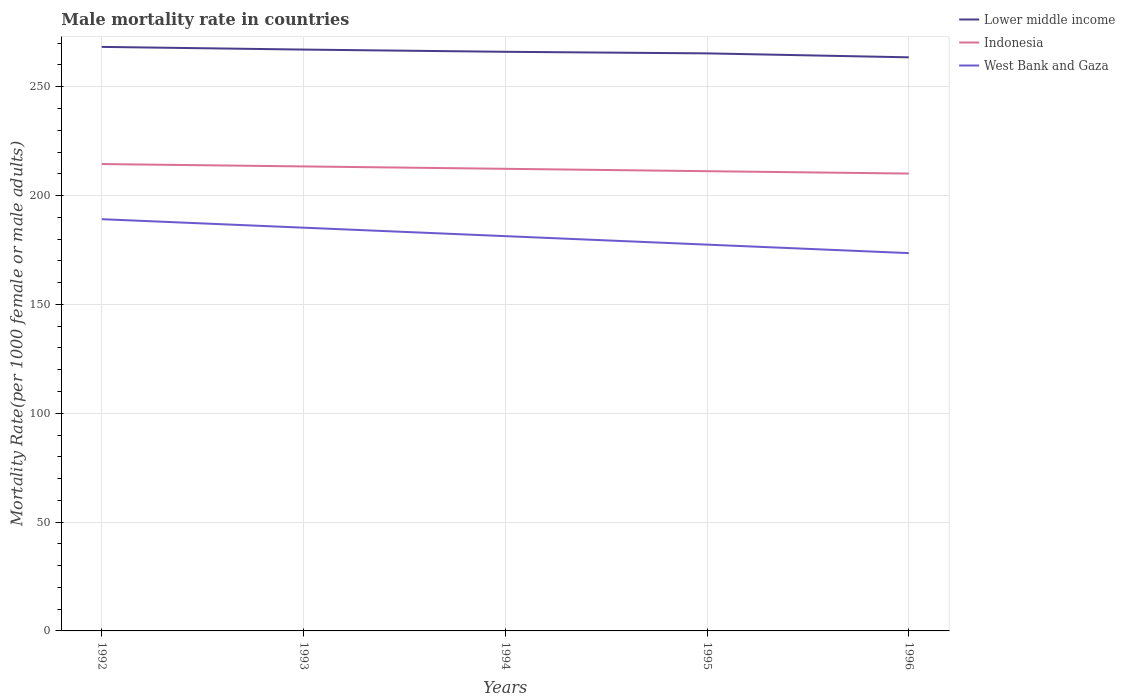Does the line corresponding to Lower middle income intersect with the line corresponding to Indonesia?
Make the answer very short. No. Across all years, what is the maximum male mortality rate in Lower middle income?
Provide a short and direct response. 263.51. What is the total male mortality rate in West Bank and Gaza in the graph?
Your response must be concise. 3.89. What is the difference between the highest and the second highest male mortality rate in West Bank and Gaza?
Provide a succinct answer. 15.58. Is the male mortality rate in West Bank and Gaza strictly greater than the male mortality rate in Indonesia over the years?
Keep it short and to the point. Yes. How many lines are there?
Give a very brief answer. 3. How many years are there in the graph?
Make the answer very short. 5. Does the graph contain grids?
Your answer should be compact. Yes. Where does the legend appear in the graph?
Ensure brevity in your answer.  Top right. How are the legend labels stacked?
Your answer should be compact. Vertical. What is the title of the graph?
Give a very brief answer. Male mortality rate in countries. What is the label or title of the X-axis?
Provide a short and direct response. Years. What is the label or title of the Y-axis?
Give a very brief answer. Mortality Rate(per 1000 female or male adults). What is the Mortality Rate(per 1000 female or male adults) of Lower middle income in 1992?
Ensure brevity in your answer.  268.3. What is the Mortality Rate(per 1000 female or male adults) in Indonesia in 1992?
Keep it short and to the point. 214.48. What is the Mortality Rate(per 1000 female or male adults) of West Bank and Gaza in 1992?
Offer a terse response. 189.15. What is the Mortality Rate(per 1000 female or male adults) of Lower middle income in 1993?
Give a very brief answer. 267.06. What is the Mortality Rate(per 1000 female or male adults) in Indonesia in 1993?
Offer a very short reply. 213.39. What is the Mortality Rate(per 1000 female or male adults) in West Bank and Gaza in 1993?
Provide a succinct answer. 185.25. What is the Mortality Rate(per 1000 female or male adults) of Lower middle income in 1994?
Offer a terse response. 266.04. What is the Mortality Rate(per 1000 female or male adults) of Indonesia in 1994?
Provide a short and direct response. 212.29. What is the Mortality Rate(per 1000 female or male adults) of West Bank and Gaza in 1994?
Make the answer very short. 181.36. What is the Mortality Rate(per 1000 female or male adults) in Lower middle income in 1995?
Your answer should be very brief. 265.32. What is the Mortality Rate(per 1000 female or male adults) in Indonesia in 1995?
Your answer should be very brief. 211.2. What is the Mortality Rate(per 1000 female or male adults) in West Bank and Gaza in 1995?
Keep it short and to the point. 177.46. What is the Mortality Rate(per 1000 female or male adults) in Lower middle income in 1996?
Your answer should be very brief. 263.51. What is the Mortality Rate(per 1000 female or male adults) of Indonesia in 1996?
Keep it short and to the point. 210.11. What is the Mortality Rate(per 1000 female or male adults) in West Bank and Gaza in 1996?
Your response must be concise. 173.57. Across all years, what is the maximum Mortality Rate(per 1000 female or male adults) in Lower middle income?
Your answer should be very brief. 268.3. Across all years, what is the maximum Mortality Rate(per 1000 female or male adults) in Indonesia?
Keep it short and to the point. 214.48. Across all years, what is the maximum Mortality Rate(per 1000 female or male adults) in West Bank and Gaza?
Offer a terse response. 189.15. Across all years, what is the minimum Mortality Rate(per 1000 female or male adults) in Lower middle income?
Offer a very short reply. 263.51. Across all years, what is the minimum Mortality Rate(per 1000 female or male adults) of Indonesia?
Offer a terse response. 210.11. Across all years, what is the minimum Mortality Rate(per 1000 female or male adults) of West Bank and Gaza?
Make the answer very short. 173.57. What is the total Mortality Rate(per 1000 female or male adults) in Lower middle income in the graph?
Provide a short and direct response. 1330.24. What is the total Mortality Rate(per 1000 female or male adults) of Indonesia in the graph?
Make the answer very short. 1061.47. What is the total Mortality Rate(per 1000 female or male adults) of West Bank and Gaza in the graph?
Make the answer very short. 906.79. What is the difference between the Mortality Rate(per 1000 female or male adults) of Lower middle income in 1992 and that in 1993?
Your response must be concise. 1.24. What is the difference between the Mortality Rate(per 1000 female or male adults) of Indonesia in 1992 and that in 1993?
Make the answer very short. 1.09. What is the difference between the Mortality Rate(per 1000 female or male adults) in West Bank and Gaza in 1992 and that in 1993?
Ensure brevity in your answer.  3.89. What is the difference between the Mortality Rate(per 1000 female or male adults) of Lower middle income in 1992 and that in 1994?
Your answer should be compact. 2.26. What is the difference between the Mortality Rate(per 1000 female or male adults) in Indonesia in 1992 and that in 1994?
Offer a very short reply. 2.19. What is the difference between the Mortality Rate(per 1000 female or male adults) of West Bank and Gaza in 1992 and that in 1994?
Give a very brief answer. 7.79. What is the difference between the Mortality Rate(per 1000 female or male adults) of Lower middle income in 1992 and that in 1995?
Give a very brief answer. 2.98. What is the difference between the Mortality Rate(per 1000 female or male adults) in Indonesia in 1992 and that in 1995?
Provide a succinct answer. 3.28. What is the difference between the Mortality Rate(per 1000 female or male adults) of West Bank and Gaza in 1992 and that in 1995?
Make the answer very short. 11.68. What is the difference between the Mortality Rate(per 1000 female or male adults) of Lower middle income in 1992 and that in 1996?
Your answer should be compact. 4.79. What is the difference between the Mortality Rate(per 1000 female or male adults) in Indonesia in 1992 and that in 1996?
Offer a terse response. 4.37. What is the difference between the Mortality Rate(per 1000 female or male adults) of West Bank and Gaza in 1992 and that in 1996?
Ensure brevity in your answer.  15.58. What is the difference between the Mortality Rate(per 1000 female or male adults) in Lower middle income in 1993 and that in 1994?
Keep it short and to the point. 1.02. What is the difference between the Mortality Rate(per 1000 female or male adults) of Indonesia in 1993 and that in 1994?
Keep it short and to the point. 1.09. What is the difference between the Mortality Rate(per 1000 female or male adults) in West Bank and Gaza in 1993 and that in 1994?
Your answer should be compact. 3.89. What is the difference between the Mortality Rate(per 1000 female or male adults) of Lower middle income in 1993 and that in 1995?
Provide a short and direct response. 1.75. What is the difference between the Mortality Rate(per 1000 female or male adults) of Indonesia in 1993 and that in 1995?
Your response must be concise. 2.19. What is the difference between the Mortality Rate(per 1000 female or male adults) of West Bank and Gaza in 1993 and that in 1995?
Give a very brief answer. 7.79. What is the difference between the Mortality Rate(per 1000 female or male adults) of Lower middle income in 1993 and that in 1996?
Your answer should be very brief. 3.56. What is the difference between the Mortality Rate(per 1000 female or male adults) in Indonesia in 1993 and that in 1996?
Your answer should be compact. 3.28. What is the difference between the Mortality Rate(per 1000 female or male adults) in West Bank and Gaza in 1993 and that in 1996?
Offer a terse response. 11.68. What is the difference between the Mortality Rate(per 1000 female or male adults) of Lower middle income in 1994 and that in 1995?
Keep it short and to the point. 0.72. What is the difference between the Mortality Rate(per 1000 female or male adults) in Indonesia in 1994 and that in 1995?
Provide a succinct answer. 1.09. What is the difference between the Mortality Rate(per 1000 female or male adults) of West Bank and Gaza in 1994 and that in 1995?
Offer a very short reply. 3.89. What is the difference between the Mortality Rate(per 1000 female or male adults) of Lower middle income in 1994 and that in 1996?
Provide a succinct answer. 2.54. What is the difference between the Mortality Rate(per 1000 female or male adults) in Indonesia in 1994 and that in 1996?
Give a very brief answer. 2.19. What is the difference between the Mortality Rate(per 1000 female or male adults) in West Bank and Gaza in 1994 and that in 1996?
Provide a short and direct response. 7.79. What is the difference between the Mortality Rate(per 1000 female or male adults) of Lower middle income in 1995 and that in 1996?
Your answer should be very brief. 1.81. What is the difference between the Mortality Rate(per 1000 female or male adults) of Indonesia in 1995 and that in 1996?
Offer a terse response. 1.09. What is the difference between the Mortality Rate(per 1000 female or male adults) in West Bank and Gaza in 1995 and that in 1996?
Your response must be concise. 3.89. What is the difference between the Mortality Rate(per 1000 female or male adults) in Lower middle income in 1992 and the Mortality Rate(per 1000 female or male adults) in Indonesia in 1993?
Your answer should be compact. 54.92. What is the difference between the Mortality Rate(per 1000 female or male adults) of Lower middle income in 1992 and the Mortality Rate(per 1000 female or male adults) of West Bank and Gaza in 1993?
Your answer should be very brief. 83.05. What is the difference between the Mortality Rate(per 1000 female or male adults) of Indonesia in 1992 and the Mortality Rate(per 1000 female or male adults) of West Bank and Gaza in 1993?
Give a very brief answer. 29.23. What is the difference between the Mortality Rate(per 1000 female or male adults) of Lower middle income in 1992 and the Mortality Rate(per 1000 female or male adults) of Indonesia in 1994?
Your answer should be very brief. 56.01. What is the difference between the Mortality Rate(per 1000 female or male adults) of Lower middle income in 1992 and the Mortality Rate(per 1000 female or male adults) of West Bank and Gaza in 1994?
Provide a short and direct response. 86.95. What is the difference between the Mortality Rate(per 1000 female or male adults) of Indonesia in 1992 and the Mortality Rate(per 1000 female or male adults) of West Bank and Gaza in 1994?
Make the answer very short. 33.12. What is the difference between the Mortality Rate(per 1000 female or male adults) in Lower middle income in 1992 and the Mortality Rate(per 1000 female or male adults) in Indonesia in 1995?
Provide a succinct answer. 57.1. What is the difference between the Mortality Rate(per 1000 female or male adults) in Lower middle income in 1992 and the Mortality Rate(per 1000 female or male adults) in West Bank and Gaza in 1995?
Offer a very short reply. 90.84. What is the difference between the Mortality Rate(per 1000 female or male adults) of Indonesia in 1992 and the Mortality Rate(per 1000 female or male adults) of West Bank and Gaza in 1995?
Ensure brevity in your answer.  37.02. What is the difference between the Mortality Rate(per 1000 female or male adults) in Lower middle income in 1992 and the Mortality Rate(per 1000 female or male adults) in Indonesia in 1996?
Give a very brief answer. 58.19. What is the difference between the Mortality Rate(per 1000 female or male adults) in Lower middle income in 1992 and the Mortality Rate(per 1000 female or male adults) in West Bank and Gaza in 1996?
Your answer should be compact. 94.73. What is the difference between the Mortality Rate(per 1000 female or male adults) of Indonesia in 1992 and the Mortality Rate(per 1000 female or male adults) of West Bank and Gaza in 1996?
Keep it short and to the point. 40.91. What is the difference between the Mortality Rate(per 1000 female or male adults) in Lower middle income in 1993 and the Mortality Rate(per 1000 female or male adults) in Indonesia in 1994?
Give a very brief answer. 54.77. What is the difference between the Mortality Rate(per 1000 female or male adults) of Lower middle income in 1993 and the Mortality Rate(per 1000 female or male adults) of West Bank and Gaza in 1994?
Provide a succinct answer. 85.71. What is the difference between the Mortality Rate(per 1000 female or male adults) in Indonesia in 1993 and the Mortality Rate(per 1000 female or male adults) in West Bank and Gaza in 1994?
Offer a very short reply. 32.03. What is the difference between the Mortality Rate(per 1000 female or male adults) in Lower middle income in 1993 and the Mortality Rate(per 1000 female or male adults) in Indonesia in 1995?
Your answer should be very brief. 55.86. What is the difference between the Mortality Rate(per 1000 female or male adults) of Lower middle income in 1993 and the Mortality Rate(per 1000 female or male adults) of West Bank and Gaza in 1995?
Ensure brevity in your answer.  89.6. What is the difference between the Mortality Rate(per 1000 female or male adults) of Indonesia in 1993 and the Mortality Rate(per 1000 female or male adults) of West Bank and Gaza in 1995?
Your answer should be very brief. 35.92. What is the difference between the Mortality Rate(per 1000 female or male adults) of Lower middle income in 1993 and the Mortality Rate(per 1000 female or male adults) of Indonesia in 1996?
Give a very brief answer. 56.96. What is the difference between the Mortality Rate(per 1000 female or male adults) in Lower middle income in 1993 and the Mortality Rate(per 1000 female or male adults) in West Bank and Gaza in 1996?
Provide a succinct answer. 93.5. What is the difference between the Mortality Rate(per 1000 female or male adults) of Indonesia in 1993 and the Mortality Rate(per 1000 female or male adults) of West Bank and Gaza in 1996?
Offer a very short reply. 39.82. What is the difference between the Mortality Rate(per 1000 female or male adults) of Lower middle income in 1994 and the Mortality Rate(per 1000 female or male adults) of Indonesia in 1995?
Your answer should be very brief. 54.84. What is the difference between the Mortality Rate(per 1000 female or male adults) in Lower middle income in 1994 and the Mortality Rate(per 1000 female or male adults) in West Bank and Gaza in 1995?
Your answer should be compact. 88.58. What is the difference between the Mortality Rate(per 1000 female or male adults) of Indonesia in 1994 and the Mortality Rate(per 1000 female or male adults) of West Bank and Gaza in 1995?
Your answer should be very brief. 34.83. What is the difference between the Mortality Rate(per 1000 female or male adults) of Lower middle income in 1994 and the Mortality Rate(per 1000 female or male adults) of Indonesia in 1996?
Offer a very short reply. 55.94. What is the difference between the Mortality Rate(per 1000 female or male adults) of Lower middle income in 1994 and the Mortality Rate(per 1000 female or male adults) of West Bank and Gaza in 1996?
Offer a terse response. 92.48. What is the difference between the Mortality Rate(per 1000 female or male adults) of Indonesia in 1994 and the Mortality Rate(per 1000 female or male adults) of West Bank and Gaza in 1996?
Your response must be concise. 38.73. What is the difference between the Mortality Rate(per 1000 female or male adults) of Lower middle income in 1995 and the Mortality Rate(per 1000 female or male adults) of Indonesia in 1996?
Make the answer very short. 55.21. What is the difference between the Mortality Rate(per 1000 female or male adults) of Lower middle income in 1995 and the Mortality Rate(per 1000 female or male adults) of West Bank and Gaza in 1996?
Your answer should be compact. 91.75. What is the difference between the Mortality Rate(per 1000 female or male adults) in Indonesia in 1995 and the Mortality Rate(per 1000 female or male adults) in West Bank and Gaza in 1996?
Offer a terse response. 37.63. What is the average Mortality Rate(per 1000 female or male adults) in Lower middle income per year?
Provide a succinct answer. 266.05. What is the average Mortality Rate(per 1000 female or male adults) of Indonesia per year?
Provide a short and direct response. 212.29. What is the average Mortality Rate(per 1000 female or male adults) of West Bank and Gaza per year?
Your response must be concise. 181.36. In the year 1992, what is the difference between the Mortality Rate(per 1000 female or male adults) of Lower middle income and Mortality Rate(per 1000 female or male adults) of Indonesia?
Your response must be concise. 53.82. In the year 1992, what is the difference between the Mortality Rate(per 1000 female or male adults) of Lower middle income and Mortality Rate(per 1000 female or male adults) of West Bank and Gaza?
Provide a short and direct response. 79.16. In the year 1992, what is the difference between the Mortality Rate(per 1000 female or male adults) of Indonesia and Mortality Rate(per 1000 female or male adults) of West Bank and Gaza?
Your answer should be very brief. 25.33. In the year 1993, what is the difference between the Mortality Rate(per 1000 female or male adults) in Lower middle income and Mortality Rate(per 1000 female or male adults) in Indonesia?
Keep it short and to the point. 53.68. In the year 1993, what is the difference between the Mortality Rate(per 1000 female or male adults) of Lower middle income and Mortality Rate(per 1000 female or male adults) of West Bank and Gaza?
Your response must be concise. 81.81. In the year 1993, what is the difference between the Mortality Rate(per 1000 female or male adults) of Indonesia and Mortality Rate(per 1000 female or male adults) of West Bank and Gaza?
Make the answer very short. 28.13. In the year 1994, what is the difference between the Mortality Rate(per 1000 female or male adults) in Lower middle income and Mortality Rate(per 1000 female or male adults) in Indonesia?
Provide a short and direct response. 53.75. In the year 1994, what is the difference between the Mortality Rate(per 1000 female or male adults) of Lower middle income and Mortality Rate(per 1000 female or male adults) of West Bank and Gaza?
Your answer should be compact. 84.69. In the year 1994, what is the difference between the Mortality Rate(per 1000 female or male adults) of Indonesia and Mortality Rate(per 1000 female or male adults) of West Bank and Gaza?
Your answer should be very brief. 30.94. In the year 1995, what is the difference between the Mortality Rate(per 1000 female or male adults) of Lower middle income and Mortality Rate(per 1000 female or male adults) of Indonesia?
Make the answer very short. 54.12. In the year 1995, what is the difference between the Mortality Rate(per 1000 female or male adults) of Lower middle income and Mortality Rate(per 1000 female or male adults) of West Bank and Gaza?
Your response must be concise. 87.86. In the year 1995, what is the difference between the Mortality Rate(per 1000 female or male adults) of Indonesia and Mortality Rate(per 1000 female or male adults) of West Bank and Gaza?
Ensure brevity in your answer.  33.74. In the year 1996, what is the difference between the Mortality Rate(per 1000 female or male adults) of Lower middle income and Mortality Rate(per 1000 female or male adults) of Indonesia?
Your answer should be very brief. 53.4. In the year 1996, what is the difference between the Mortality Rate(per 1000 female or male adults) in Lower middle income and Mortality Rate(per 1000 female or male adults) in West Bank and Gaza?
Provide a succinct answer. 89.94. In the year 1996, what is the difference between the Mortality Rate(per 1000 female or male adults) of Indonesia and Mortality Rate(per 1000 female or male adults) of West Bank and Gaza?
Give a very brief answer. 36.54. What is the ratio of the Mortality Rate(per 1000 female or male adults) of Lower middle income in 1992 to that in 1993?
Provide a short and direct response. 1. What is the ratio of the Mortality Rate(per 1000 female or male adults) in Indonesia in 1992 to that in 1993?
Keep it short and to the point. 1.01. What is the ratio of the Mortality Rate(per 1000 female or male adults) of Lower middle income in 1992 to that in 1994?
Provide a short and direct response. 1.01. What is the ratio of the Mortality Rate(per 1000 female or male adults) of Indonesia in 1992 to that in 1994?
Keep it short and to the point. 1.01. What is the ratio of the Mortality Rate(per 1000 female or male adults) in West Bank and Gaza in 1992 to that in 1994?
Provide a succinct answer. 1.04. What is the ratio of the Mortality Rate(per 1000 female or male adults) in Lower middle income in 1992 to that in 1995?
Provide a short and direct response. 1.01. What is the ratio of the Mortality Rate(per 1000 female or male adults) of Indonesia in 1992 to that in 1995?
Ensure brevity in your answer.  1.02. What is the ratio of the Mortality Rate(per 1000 female or male adults) of West Bank and Gaza in 1992 to that in 1995?
Offer a very short reply. 1.07. What is the ratio of the Mortality Rate(per 1000 female or male adults) in Lower middle income in 1992 to that in 1996?
Your response must be concise. 1.02. What is the ratio of the Mortality Rate(per 1000 female or male adults) of Indonesia in 1992 to that in 1996?
Offer a terse response. 1.02. What is the ratio of the Mortality Rate(per 1000 female or male adults) in West Bank and Gaza in 1992 to that in 1996?
Provide a succinct answer. 1.09. What is the ratio of the Mortality Rate(per 1000 female or male adults) of Lower middle income in 1993 to that in 1994?
Offer a terse response. 1. What is the ratio of the Mortality Rate(per 1000 female or male adults) in Indonesia in 1993 to that in 1994?
Give a very brief answer. 1.01. What is the ratio of the Mortality Rate(per 1000 female or male adults) in West Bank and Gaza in 1993 to that in 1994?
Your response must be concise. 1.02. What is the ratio of the Mortality Rate(per 1000 female or male adults) of Lower middle income in 1993 to that in 1995?
Give a very brief answer. 1.01. What is the ratio of the Mortality Rate(per 1000 female or male adults) of Indonesia in 1993 to that in 1995?
Keep it short and to the point. 1.01. What is the ratio of the Mortality Rate(per 1000 female or male adults) in West Bank and Gaza in 1993 to that in 1995?
Offer a very short reply. 1.04. What is the ratio of the Mortality Rate(per 1000 female or male adults) in Lower middle income in 1993 to that in 1996?
Offer a very short reply. 1.01. What is the ratio of the Mortality Rate(per 1000 female or male adults) of Indonesia in 1993 to that in 1996?
Make the answer very short. 1.02. What is the ratio of the Mortality Rate(per 1000 female or male adults) in West Bank and Gaza in 1993 to that in 1996?
Provide a succinct answer. 1.07. What is the ratio of the Mortality Rate(per 1000 female or male adults) in Lower middle income in 1994 to that in 1995?
Your response must be concise. 1. What is the ratio of the Mortality Rate(per 1000 female or male adults) of West Bank and Gaza in 1994 to that in 1995?
Offer a very short reply. 1.02. What is the ratio of the Mortality Rate(per 1000 female or male adults) in Lower middle income in 1994 to that in 1996?
Ensure brevity in your answer.  1.01. What is the ratio of the Mortality Rate(per 1000 female or male adults) of Indonesia in 1994 to that in 1996?
Your response must be concise. 1.01. What is the ratio of the Mortality Rate(per 1000 female or male adults) in West Bank and Gaza in 1994 to that in 1996?
Offer a very short reply. 1.04. What is the ratio of the Mortality Rate(per 1000 female or male adults) of Lower middle income in 1995 to that in 1996?
Your response must be concise. 1.01. What is the ratio of the Mortality Rate(per 1000 female or male adults) of Indonesia in 1995 to that in 1996?
Offer a terse response. 1.01. What is the ratio of the Mortality Rate(per 1000 female or male adults) of West Bank and Gaza in 1995 to that in 1996?
Your answer should be compact. 1.02. What is the difference between the highest and the second highest Mortality Rate(per 1000 female or male adults) of Lower middle income?
Your response must be concise. 1.24. What is the difference between the highest and the second highest Mortality Rate(per 1000 female or male adults) of Indonesia?
Your answer should be very brief. 1.09. What is the difference between the highest and the second highest Mortality Rate(per 1000 female or male adults) of West Bank and Gaza?
Make the answer very short. 3.89. What is the difference between the highest and the lowest Mortality Rate(per 1000 female or male adults) in Lower middle income?
Offer a very short reply. 4.79. What is the difference between the highest and the lowest Mortality Rate(per 1000 female or male adults) of Indonesia?
Offer a terse response. 4.37. What is the difference between the highest and the lowest Mortality Rate(per 1000 female or male adults) of West Bank and Gaza?
Your answer should be compact. 15.58. 